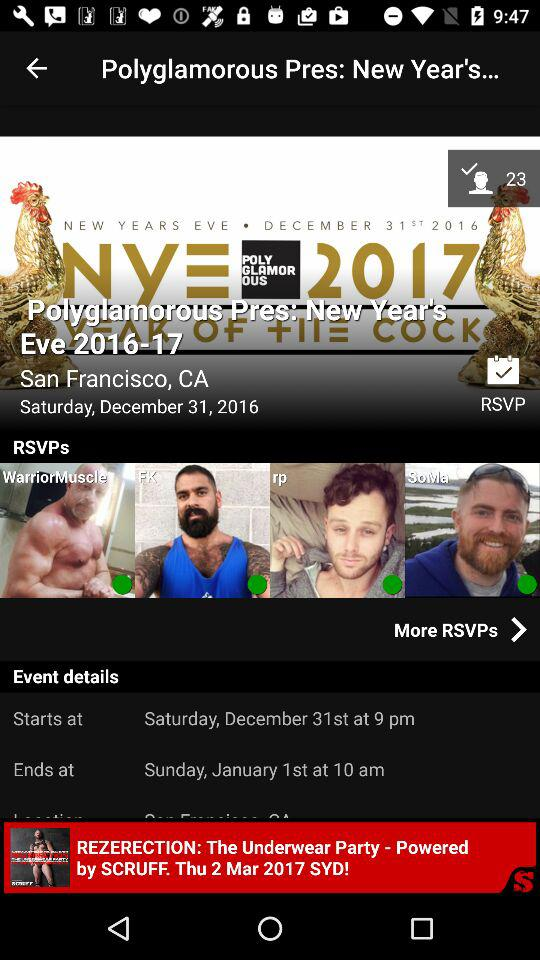On which day will "The Underwear Party" be held? "The Underwear Party" will be held on Thursday. 